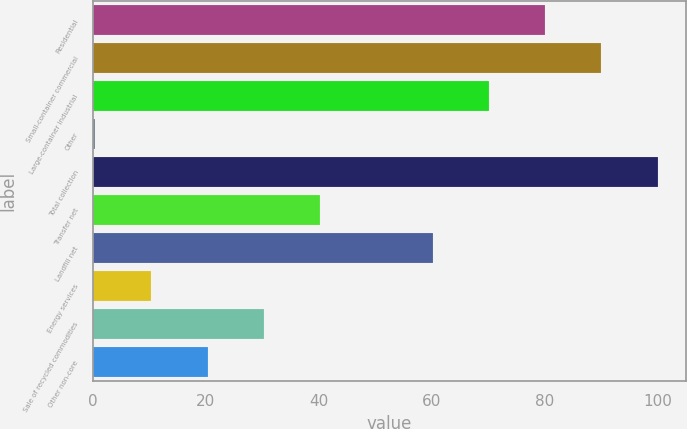Convert chart. <chart><loc_0><loc_0><loc_500><loc_500><bar_chart><fcel>Residential<fcel>Small-container commercial<fcel>Large-container industrial<fcel>Other<fcel>Total collection<fcel>Transfer net<fcel>Landfill net<fcel>Energy services<fcel>Sale of recycled commodities<fcel>Other non-core<nl><fcel>80.08<fcel>90.04<fcel>70.12<fcel>0.4<fcel>100<fcel>40.24<fcel>60.16<fcel>10.36<fcel>30.28<fcel>20.32<nl></chart> 